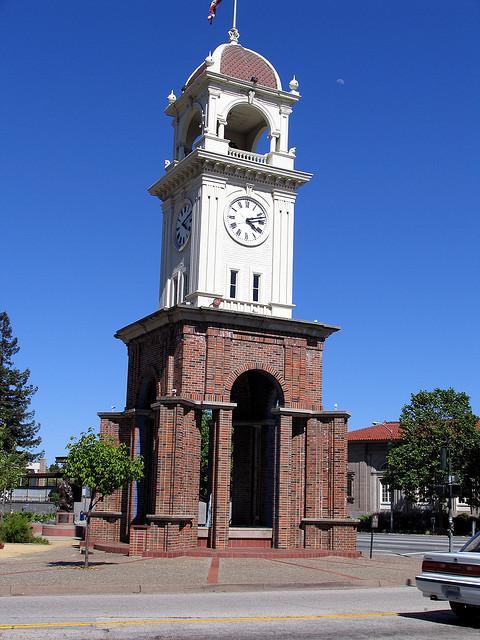What can someone know by looking at the white tower? Please explain your reasoning. time. The white tower on the building has a clock on each side so people can tell the time by looking at it. 